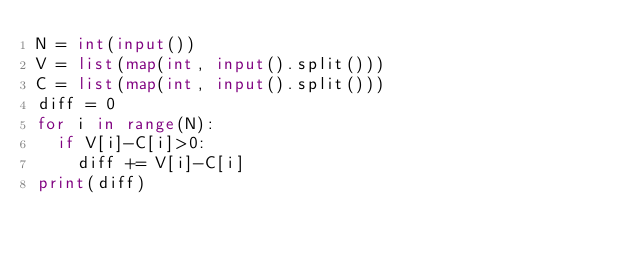Convert code to text. <code><loc_0><loc_0><loc_500><loc_500><_Python_>N = int(input())
V = list(map(int, input().split()))
C = list(map(int, input().split()))
diff = 0
for i in range(N):
  if V[i]-C[i]>0:
    diff += V[i]-C[i]
print(diff)</code> 